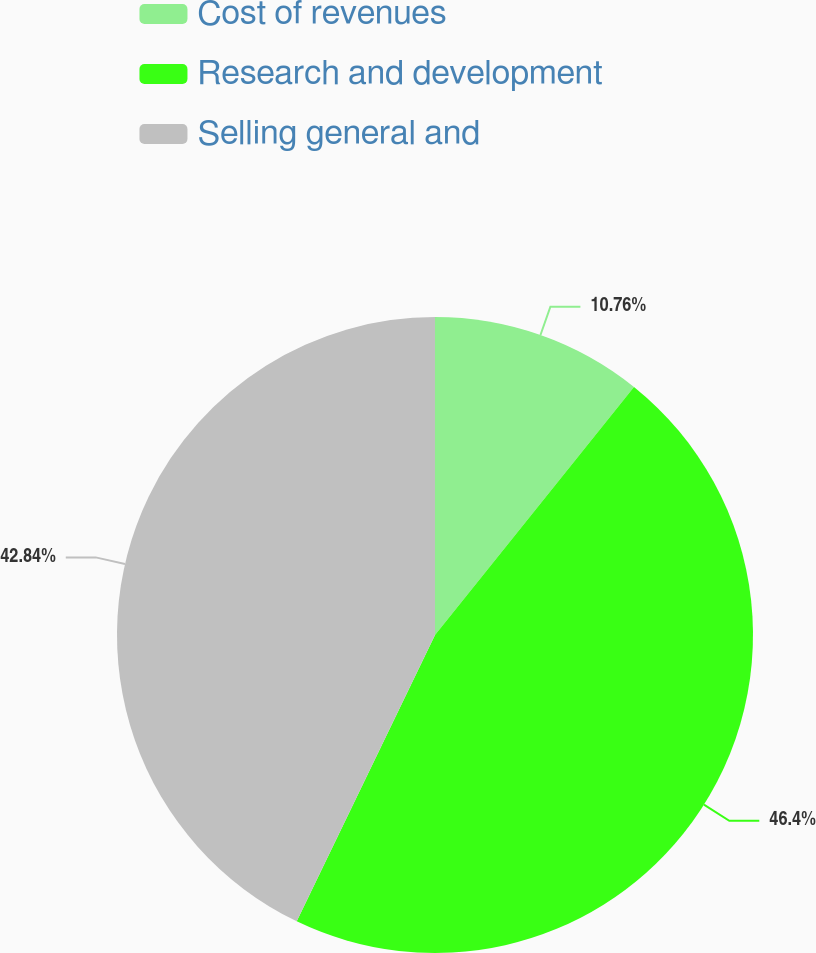Convert chart to OTSL. <chart><loc_0><loc_0><loc_500><loc_500><pie_chart><fcel>Cost of revenues<fcel>Research and development<fcel>Selling general and<nl><fcel>10.76%<fcel>46.4%<fcel>42.84%<nl></chart> 